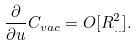<formula> <loc_0><loc_0><loc_500><loc_500>\frac { \partial } { \partial u } C _ { v a c } = O [ R _ { . . } ^ { 2 } ] .</formula> 